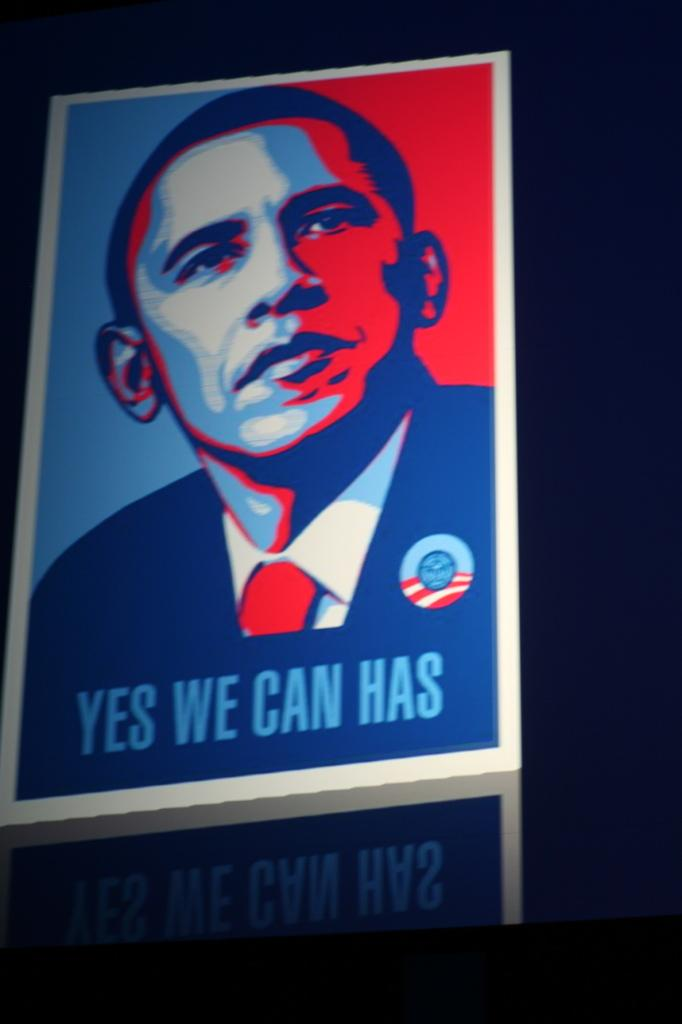Provide a one-sentence caption for the provided image. A yes we can has poster of the red and blue colored image of Obama. 